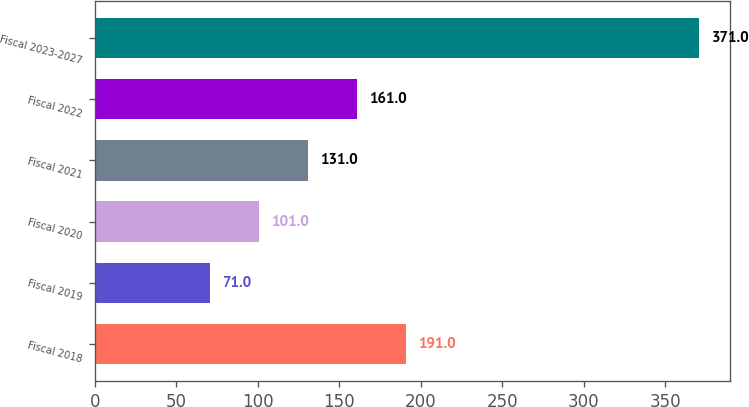<chart> <loc_0><loc_0><loc_500><loc_500><bar_chart><fcel>Fiscal 2018<fcel>Fiscal 2019<fcel>Fiscal 2020<fcel>Fiscal 2021<fcel>Fiscal 2022<fcel>Fiscal 2023-2027<nl><fcel>191<fcel>71<fcel>101<fcel>131<fcel>161<fcel>371<nl></chart> 